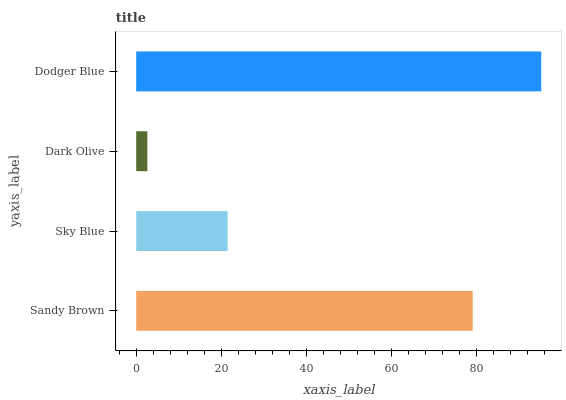Is Dark Olive the minimum?
Answer yes or no. Yes. Is Dodger Blue the maximum?
Answer yes or no. Yes. Is Sky Blue the minimum?
Answer yes or no. No. Is Sky Blue the maximum?
Answer yes or no. No. Is Sandy Brown greater than Sky Blue?
Answer yes or no. Yes. Is Sky Blue less than Sandy Brown?
Answer yes or no. Yes. Is Sky Blue greater than Sandy Brown?
Answer yes or no. No. Is Sandy Brown less than Sky Blue?
Answer yes or no. No. Is Sandy Brown the high median?
Answer yes or no. Yes. Is Sky Blue the low median?
Answer yes or no. Yes. Is Sky Blue the high median?
Answer yes or no. No. Is Sandy Brown the low median?
Answer yes or no. No. 